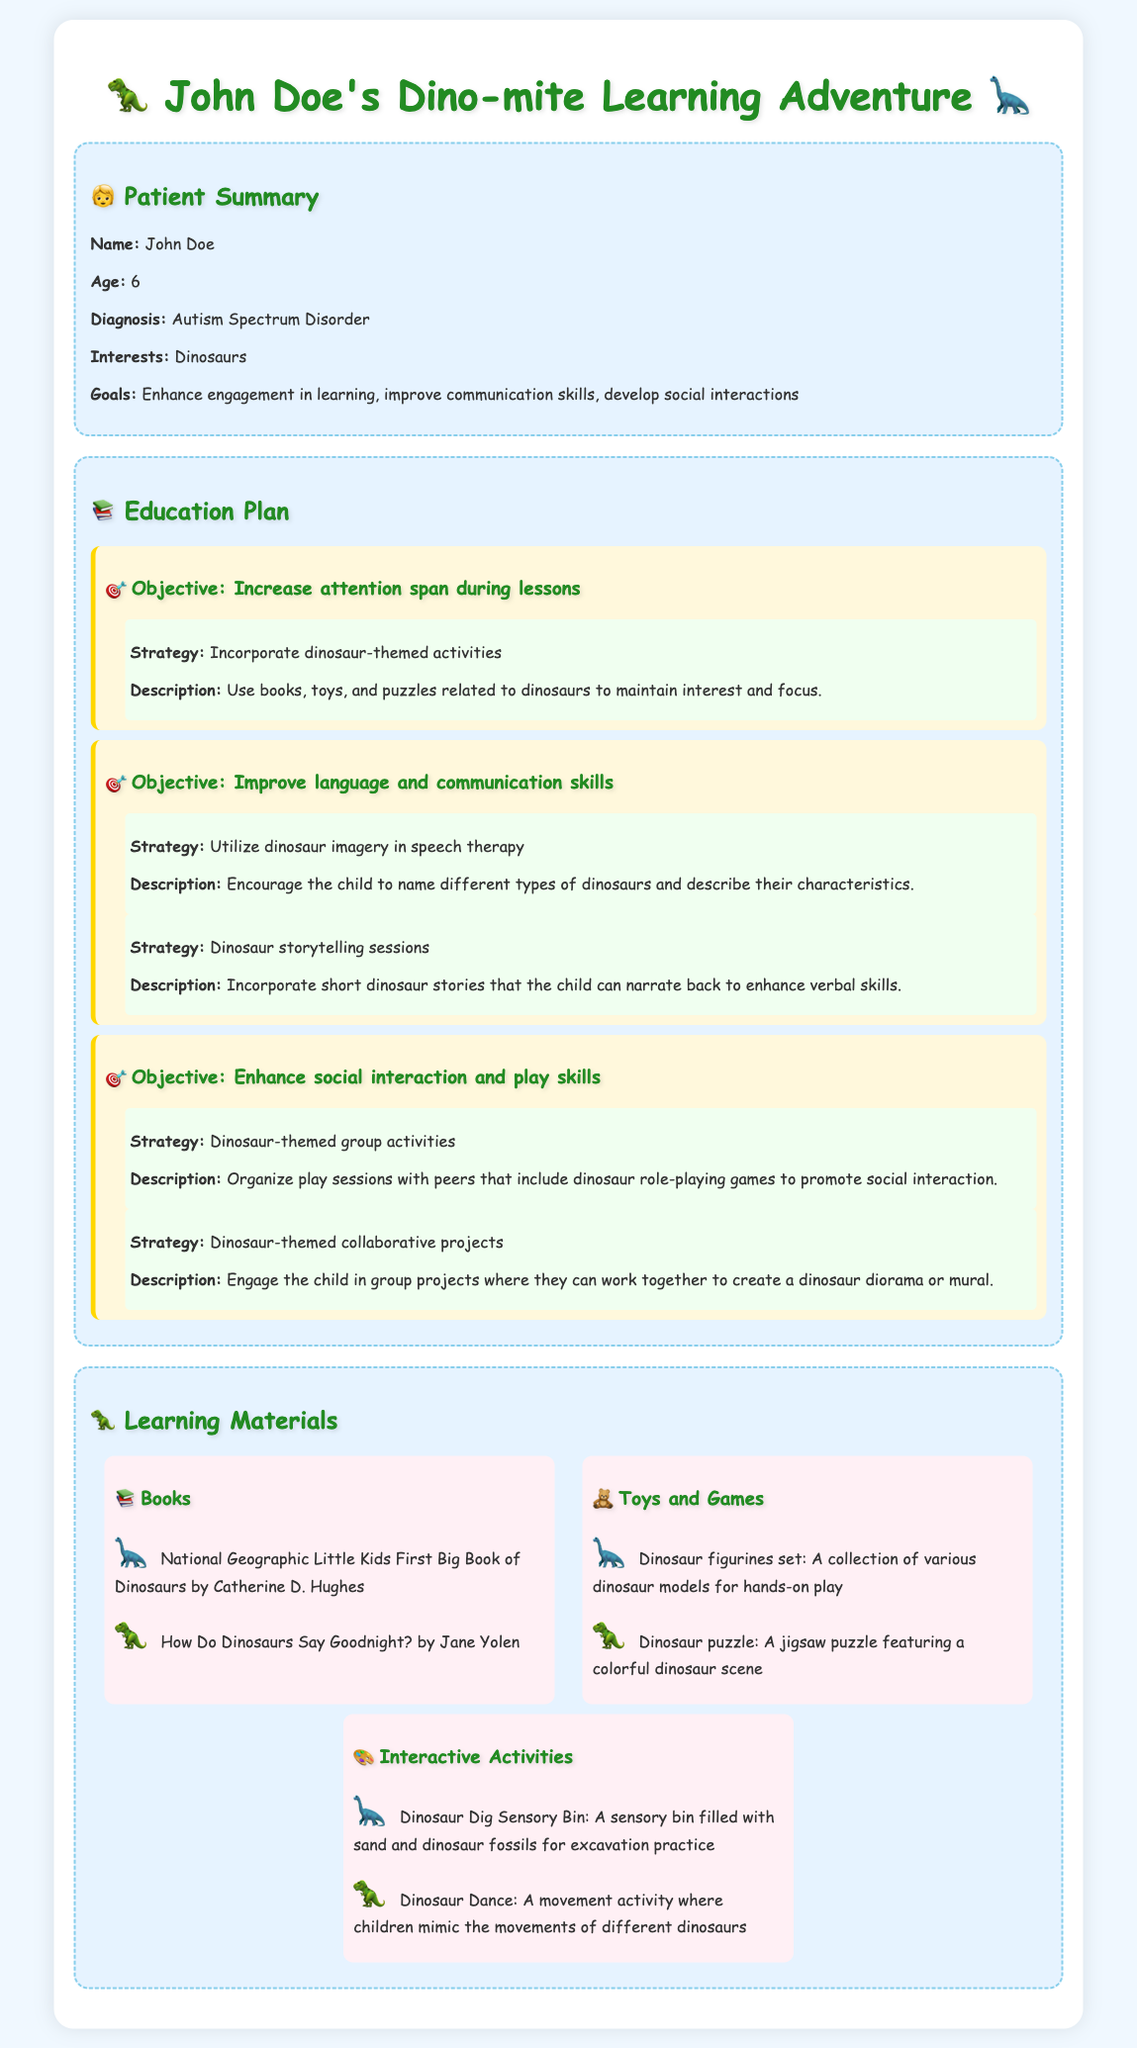What is the patient's name? The patient's name is provided in the Patient Summary section of the document.
Answer: John Doe What is the patient's age? The patient's age is mentioned right after the name in the Patient Summary.
Answer: 6 What is the main focus of the education plan? The education plan includes specific objectives aimed at enhancing various skills, highlighting the key focus areas of the plan.
Answer: Increase attention span, improve communication skills, develop social interactions What is one of the strategies for improving communication skills? The document lists multiple strategies under the specific objective for communication skills, detailing methods for enhancement.
Answer: Utilize dinosaur imagery in speech therapy What are the types of materials listed for learning? The document categorizes learning materials into distinct sections, each containing different types such as books, toys, and interactive activities.
Answer: Books, Toys and Games, Interactive Activities What type of play session is suggested to enhance social interaction? The document outlines specific types of activities that are designed to improve social skills among peers.
Answer: Dinosaur-themed group activities How many dinosaur-themed storytelling strategies are mentioned? The document specifies two strategies under the communication skills objective, so this requires counting those references.
Answer: 2 What is one example of a dinosaur-themed interactive activity? The document provides specific examples of activities that promote engagement related to dinosaurs.
Answer: Dinosaur Dig Sensory Bin What book is recommended for dinosaur reading? The document lists specific book titles for reading, offering examples of available resources related to dinosaurs.
Answer: National Geographic Little Kids First Big Book of Dinosaurs 